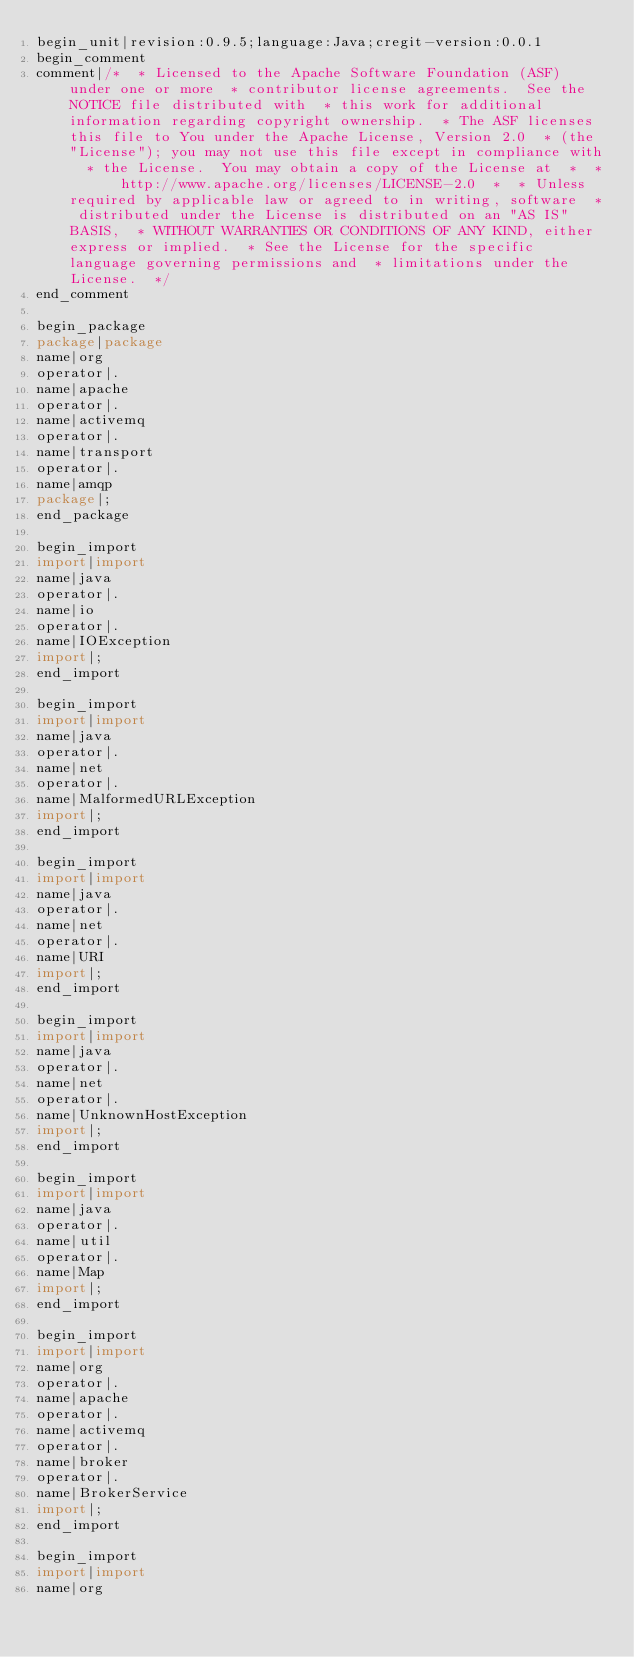<code> <loc_0><loc_0><loc_500><loc_500><_Java_>begin_unit|revision:0.9.5;language:Java;cregit-version:0.0.1
begin_comment
comment|/*  * Licensed to the Apache Software Foundation (ASF) under one or more  * contributor license agreements.  See the NOTICE file distributed with  * this work for additional information regarding copyright ownership.  * The ASF licenses this file to You under the Apache License, Version 2.0  * (the "License"); you may not use this file except in compliance with  * the License.  You may obtain a copy of the License at  *  *      http://www.apache.org/licenses/LICENSE-2.0  *  * Unless required by applicable law or agreed to in writing, software  * distributed under the License is distributed on an "AS IS" BASIS,  * WITHOUT WARRANTIES OR CONDITIONS OF ANY KIND, either express or implied.  * See the License for the specific language governing permissions and  * limitations under the License.  */
end_comment

begin_package
package|package
name|org
operator|.
name|apache
operator|.
name|activemq
operator|.
name|transport
operator|.
name|amqp
package|;
end_package

begin_import
import|import
name|java
operator|.
name|io
operator|.
name|IOException
import|;
end_import

begin_import
import|import
name|java
operator|.
name|net
operator|.
name|MalformedURLException
import|;
end_import

begin_import
import|import
name|java
operator|.
name|net
operator|.
name|URI
import|;
end_import

begin_import
import|import
name|java
operator|.
name|net
operator|.
name|UnknownHostException
import|;
end_import

begin_import
import|import
name|java
operator|.
name|util
operator|.
name|Map
import|;
end_import

begin_import
import|import
name|org
operator|.
name|apache
operator|.
name|activemq
operator|.
name|broker
operator|.
name|BrokerService
import|;
end_import

begin_import
import|import
name|org</code> 